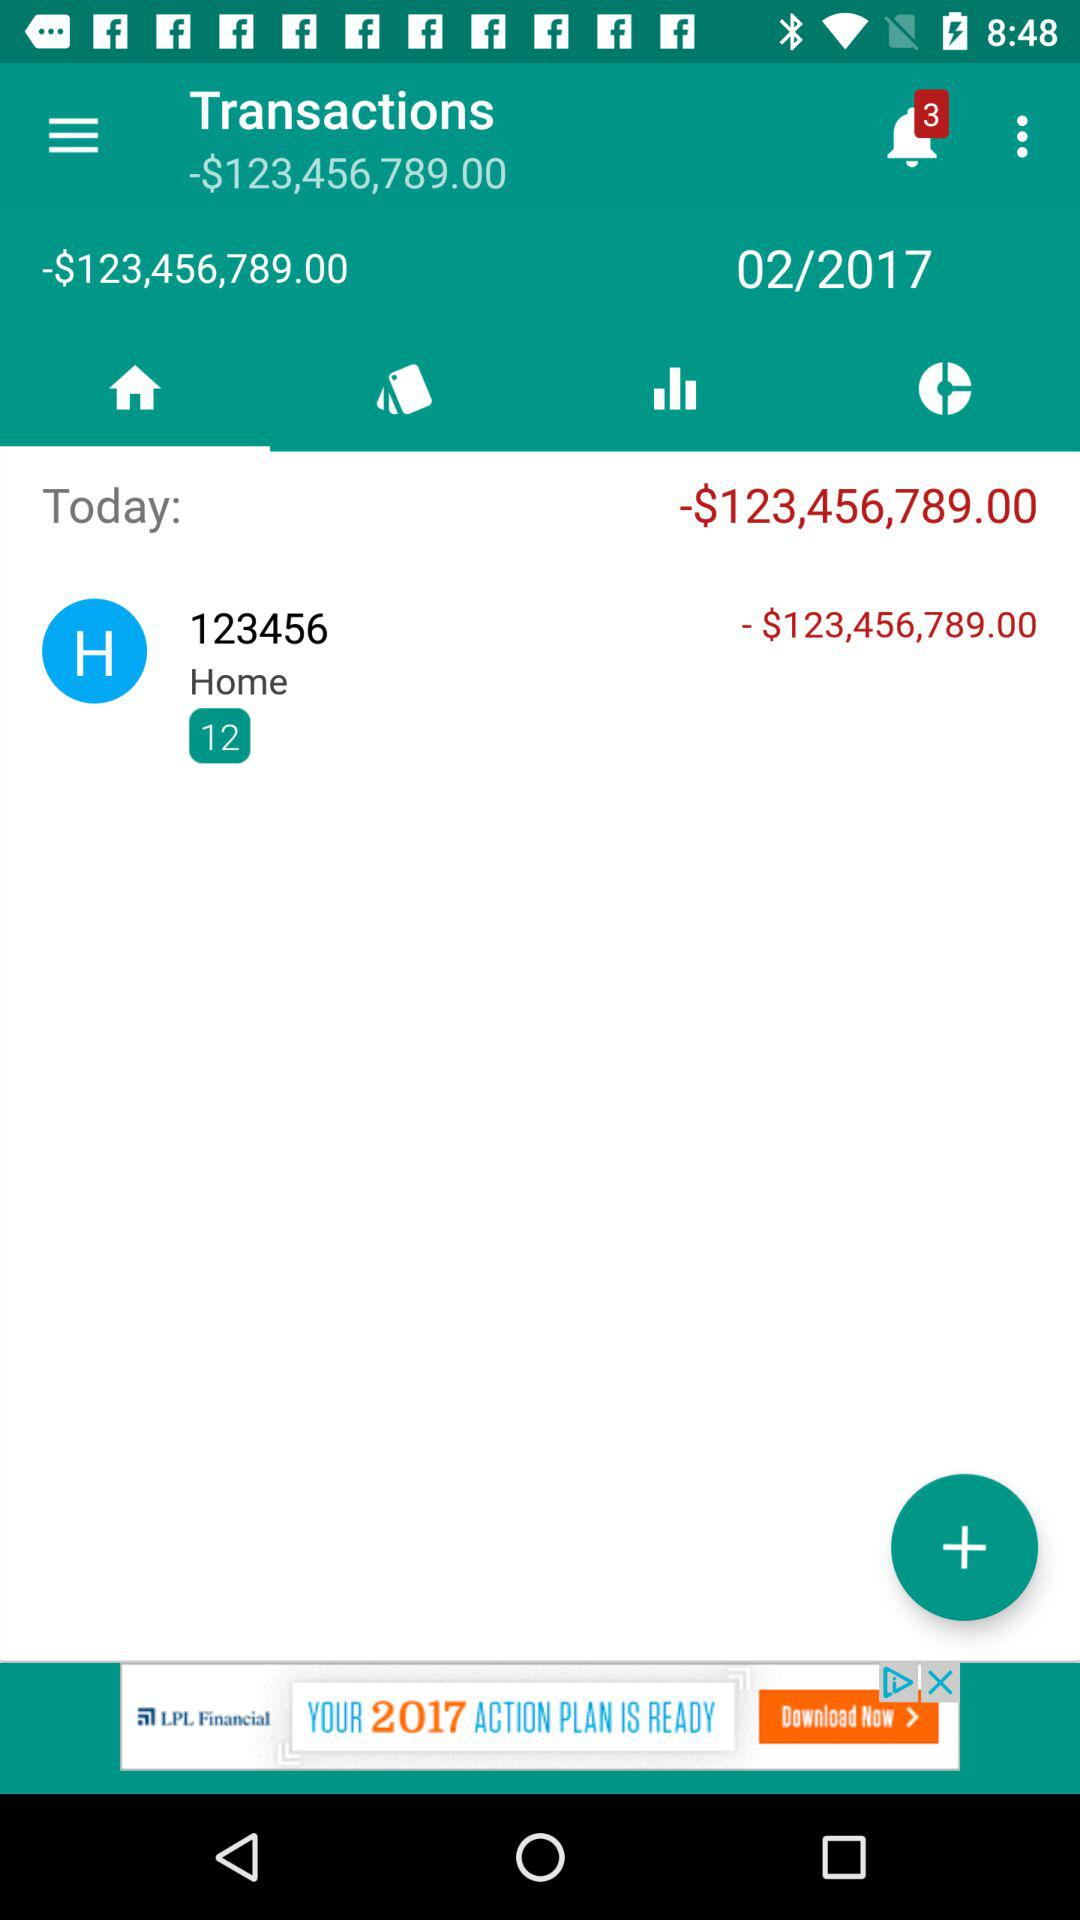What is the date? The date is "02/2017". 